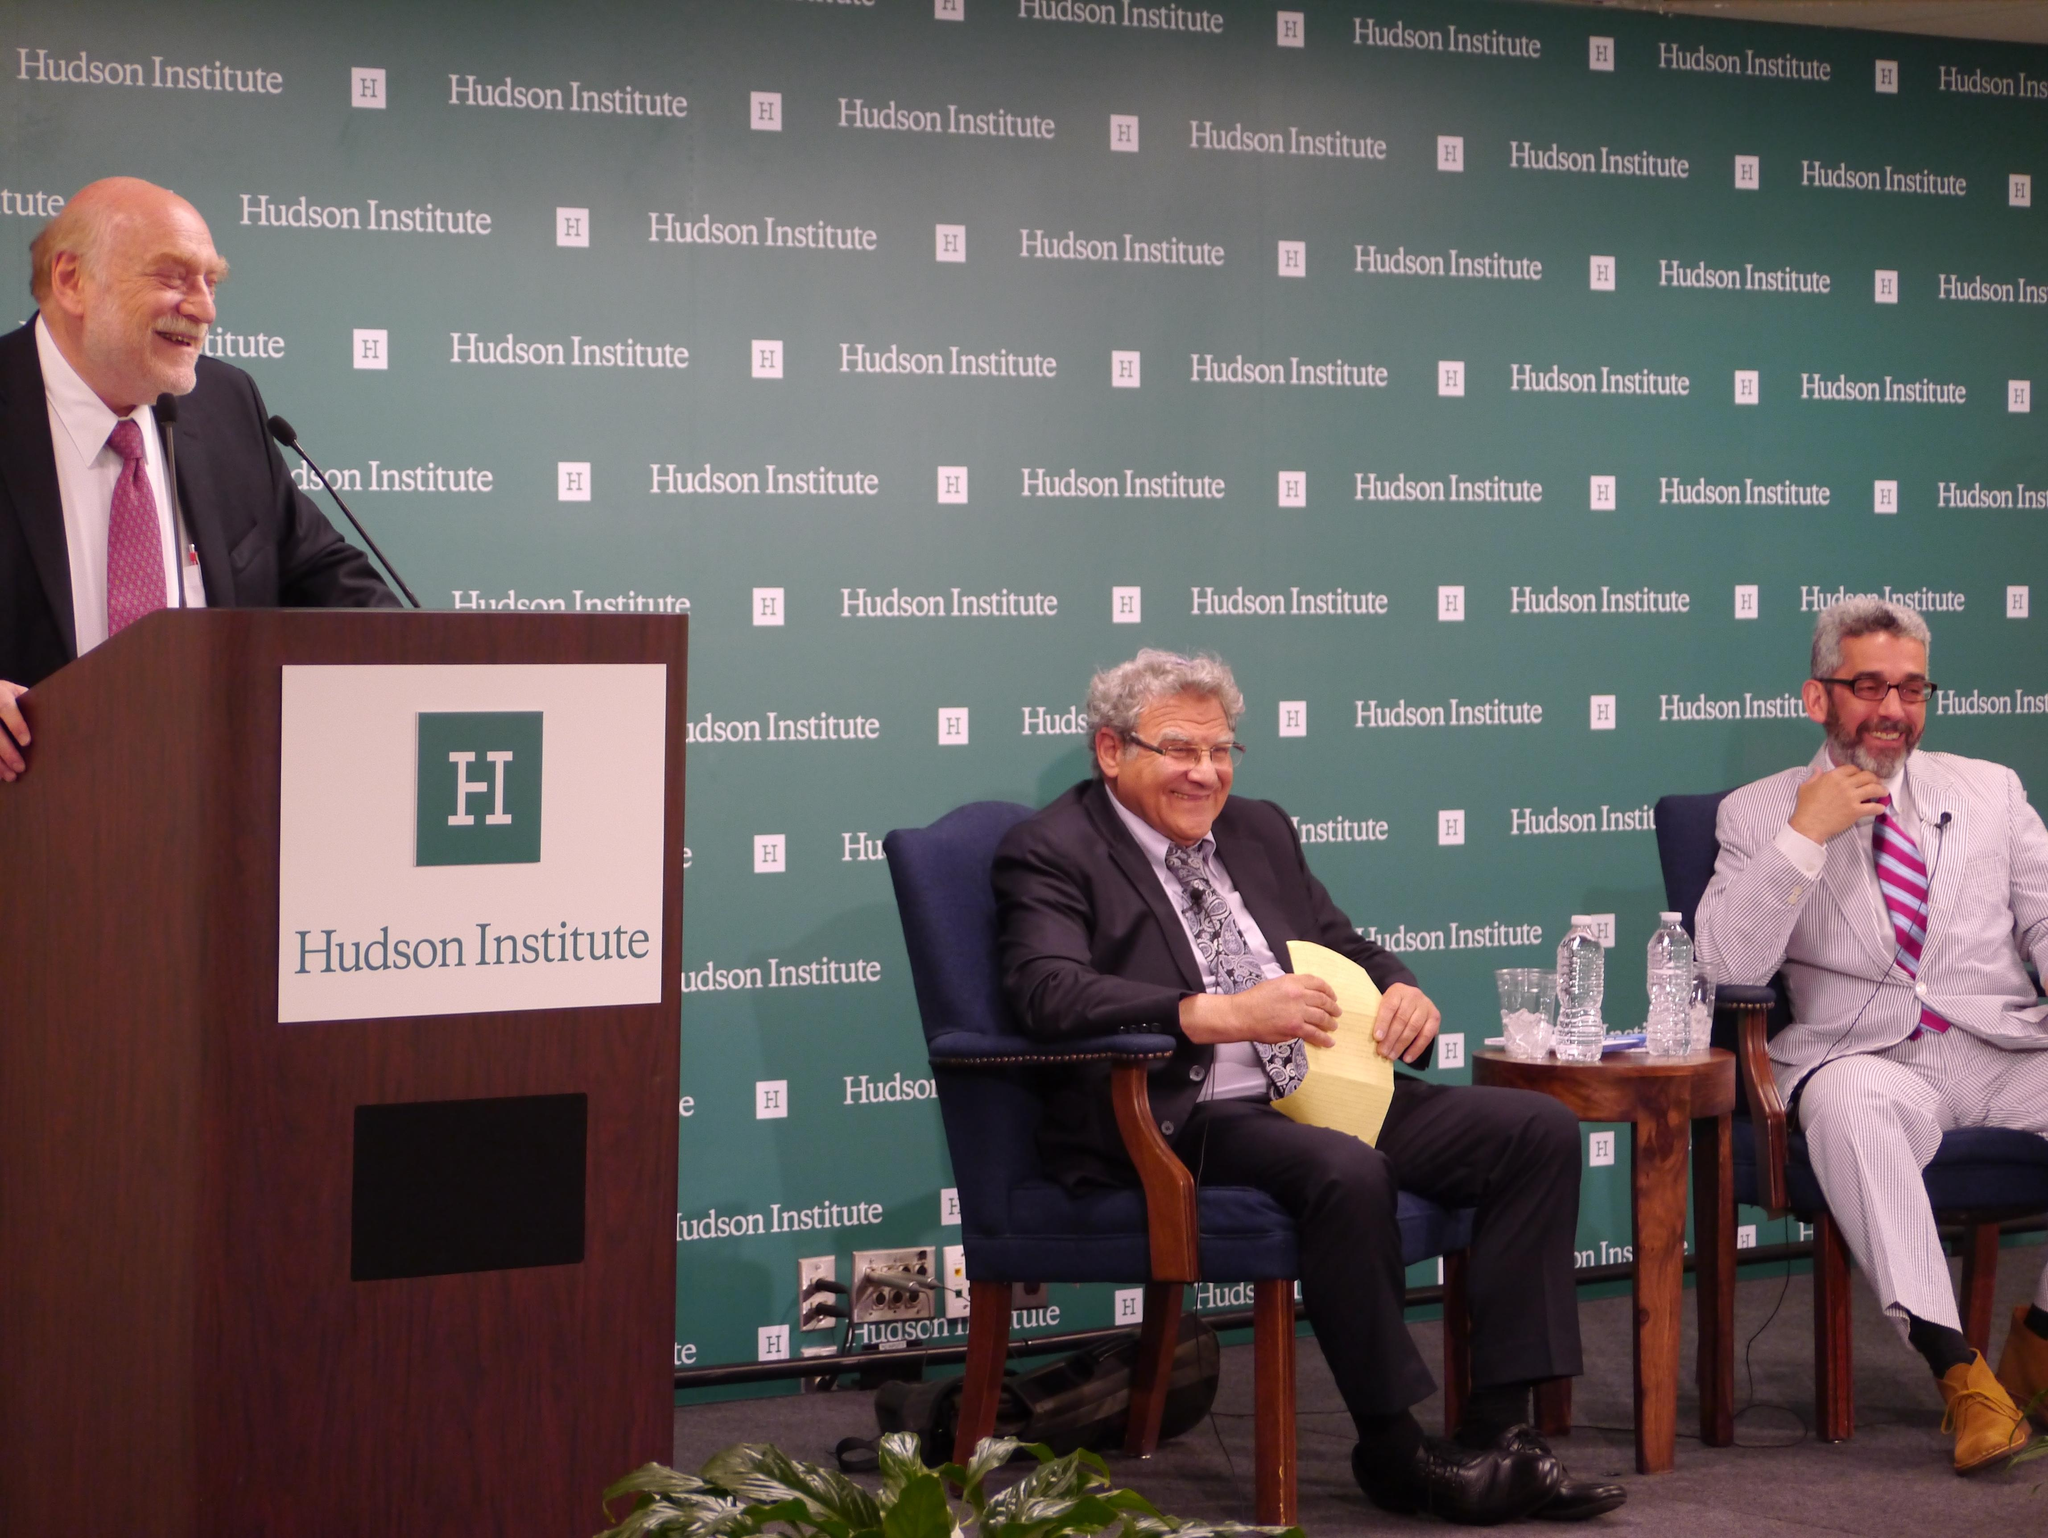Who or what can be seen in the image? There are people in the image. What object is present that might be used for speaking or presenting? There is a podium in the image. What type of furniture is visible in the image? There are chairs in the image. What items can be seen that might contain liquid? There are bottles in the image. What piece of furniture is present that might be used for placing objects? There is a table in the image. What type of living organism is present in the image? There is a plant in the image. What can be seen in the background of the image that might convey information or a message? There is a banner with text in the background of the image. What type of cloth is draped over the podium in the image? There is no cloth draped over the podium in the image; it is not mentioned in the provided facts. What type of celebration is taking place in the image? There is no indication of a celebration or birthday in the image; it is not mentioned in the provided facts. 